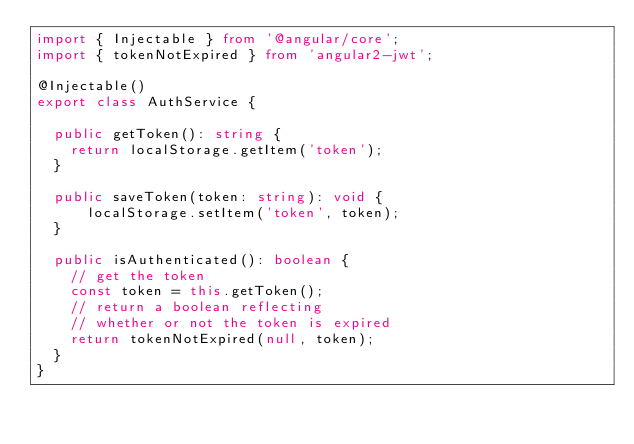Convert code to text. <code><loc_0><loc_0><loc_500><loc_500><_TypeScript_>import { Injectable } from '@angular/core';
import { tokenNotExpired } from 'angular2-jwt';

@Injectable()
export class AuthService {

  public getToken(): string {
    return localStorage.getItem('token');
  }

  public saveToken(token: string): void {
      localStorage.setItem('token', token);
  }

  public isAuthenticated(): boolean {
    // get the token
    const token = this.getToken();
    // return a boolean reflecting
    // whether or not the token is expired
    return tokenNotExpired(null, token);
  }
}
</code> 